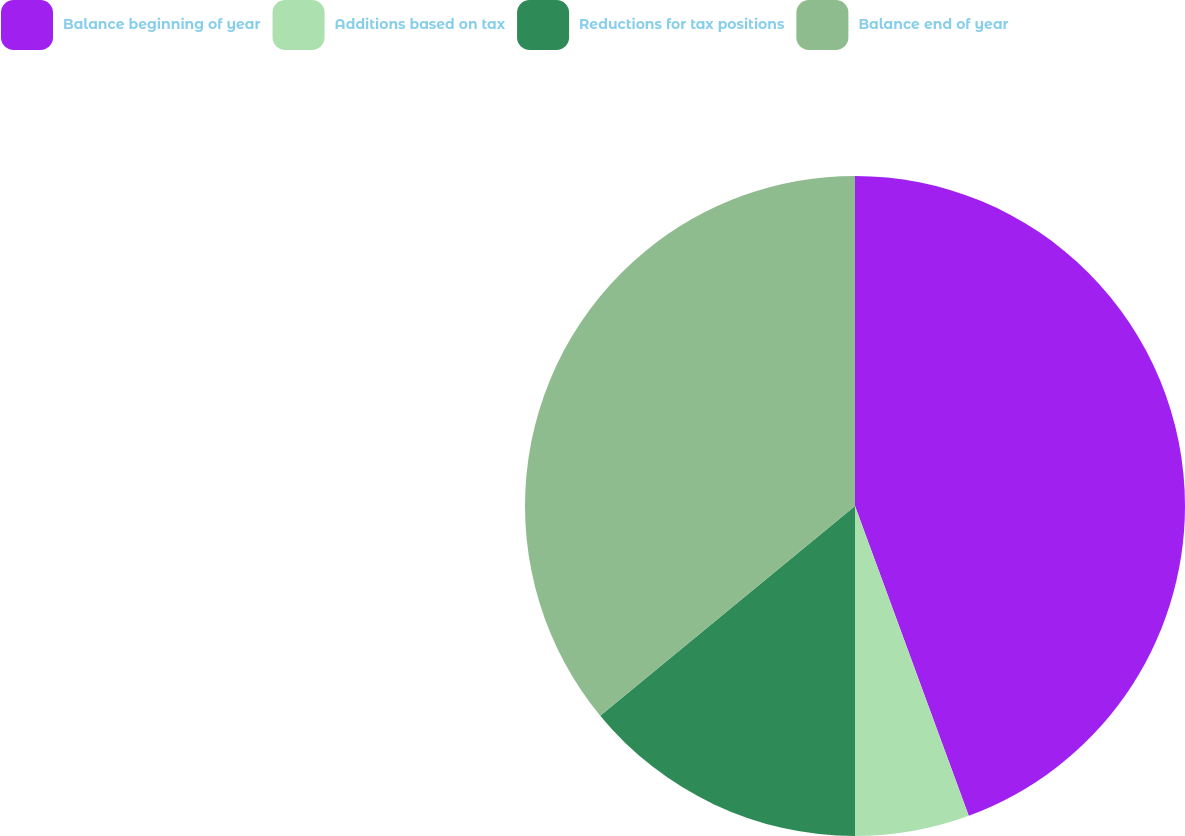Convert chart to OTSL. <chart><loc_0><loc_0><loc_500><loc_500><pie_chart><fcel>Balance beginning of year<fcel>Additions based on tax<fcel>Reductions for tax positions<fcel>Balance end of year<nl><fcel>44.4%<fcel>5.6%<fcel>14.04%<fcel>35.96%<nl></chart> 